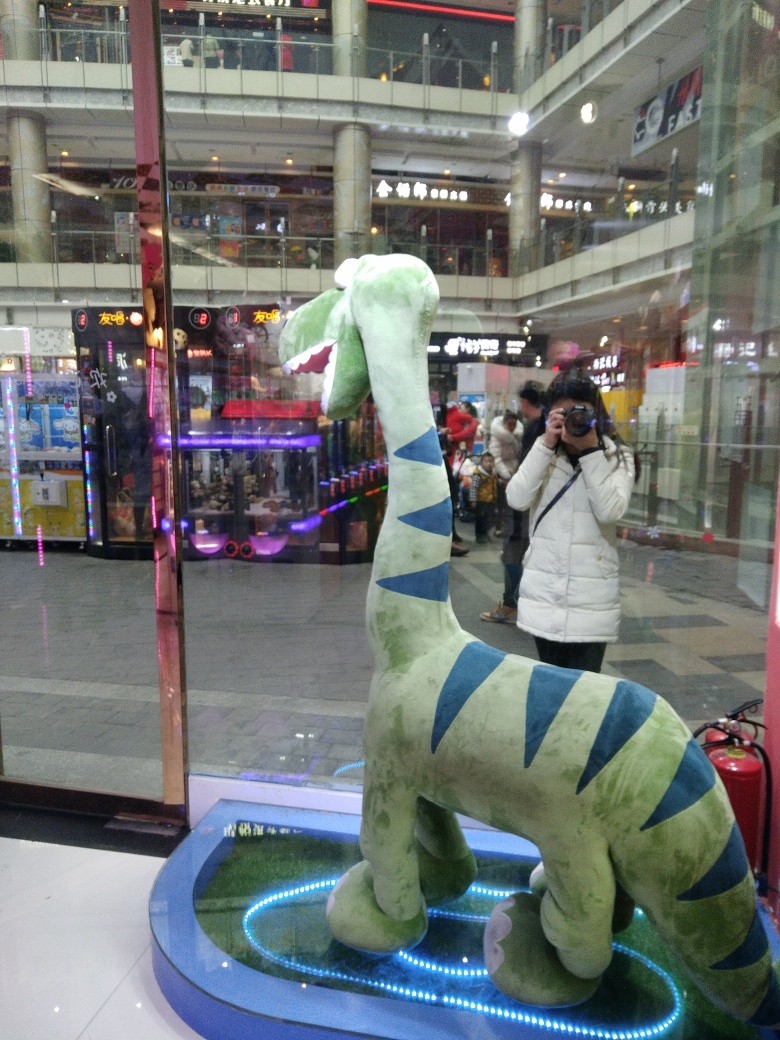Are the details and textures of the characters inside the glass showcase clear? The details and textures of the characters inside the glass showcase exhibit mild clarity, but reflections and lighting conditions partially obscure the view, rendering a comprehensive assessment challenging. 